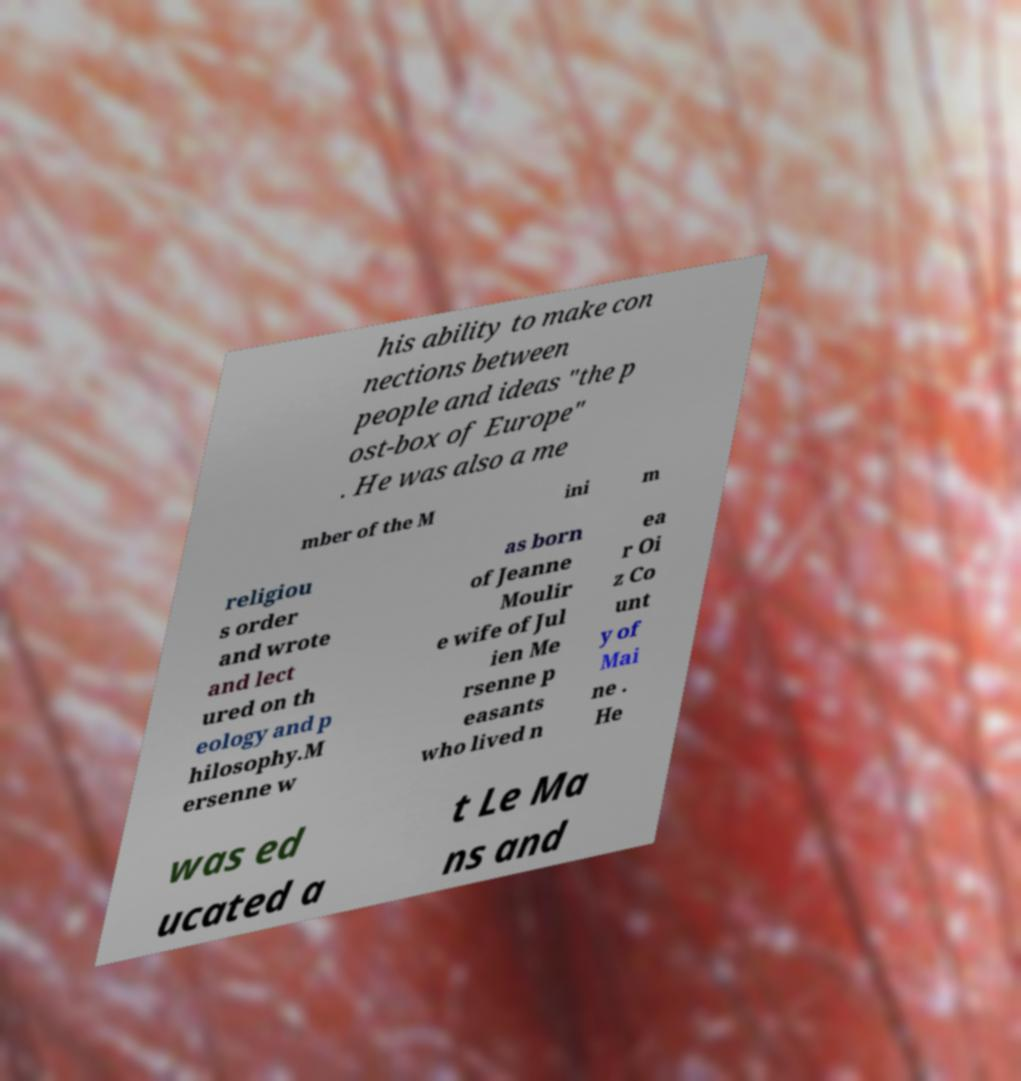What messages or text are displayed in this image? I need them in a readable, typed format. his ability to make con nections between people and ideas "the p ost-box of Europe" . He was also a me mber of the M ini m religiou s order and wrote and lect ured on th eology and p hilosophy.M ersenne w as born of Jeanne Moulir e wife of Jul ien Me rsenne p easants who lived n ea r Oi z Co unt y of Mai ne . He was ed ucated a t Le Ma ns and 